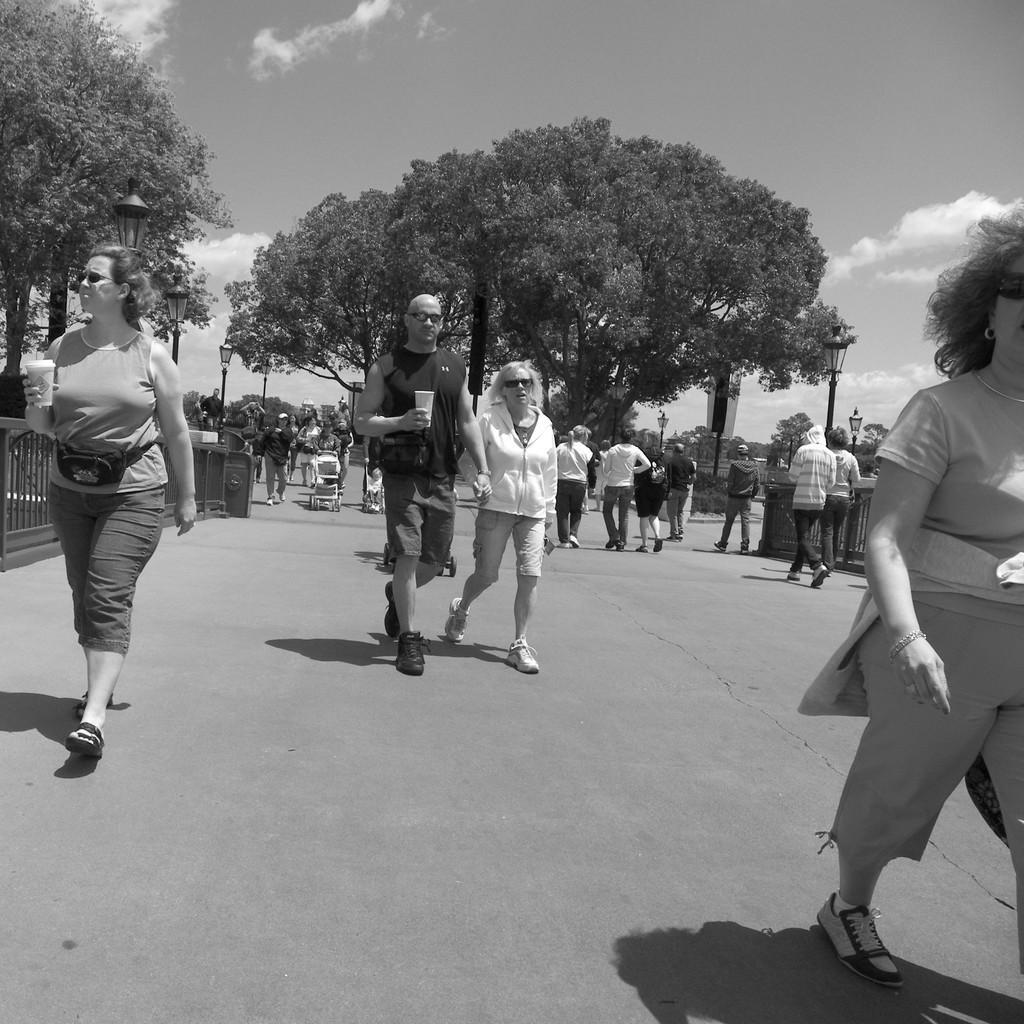Describe this image in one or two sentences. This is a black and white image. Here I can see many people are walking on the road. In the background there are many trees and light poles. On the left side there is a railing. In the middle of the image there are two persons holding two baby chairs and walking. At the top of the image I can see the sky and clouds. 